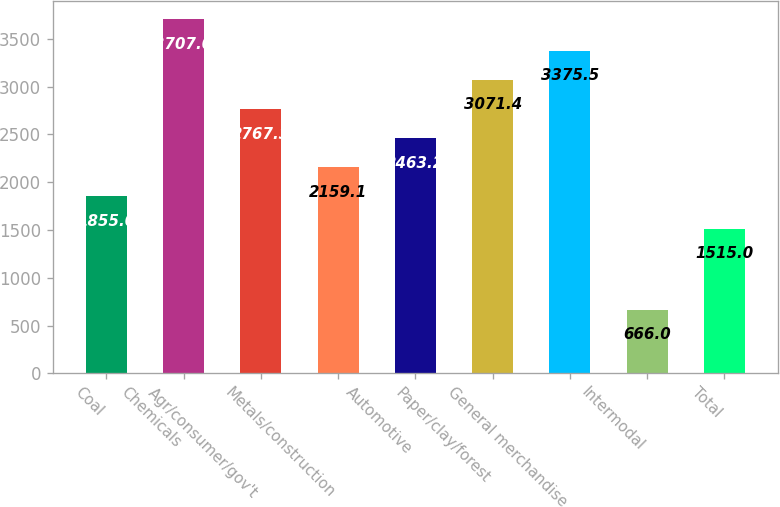<chart> <loc_0><loc_0><loc_500><loc_500><bar_chart><fcel>Coal<fcel>Chemicals<fcel>Agr/consumer/gov't<fcel>Metals/construction<fcel>Automotive<fcel>Paper/clay/forest<fcel>General merchandise<fcel>Intermodal<fcel>Total<nl><fcel>1855<fcel>3707<fcel>2767.3<fcel>2159.1<fcel>2463.2<fcel>3071.4<fcel>3375.5<fcel>666<fcel>1515<nl></chart> 